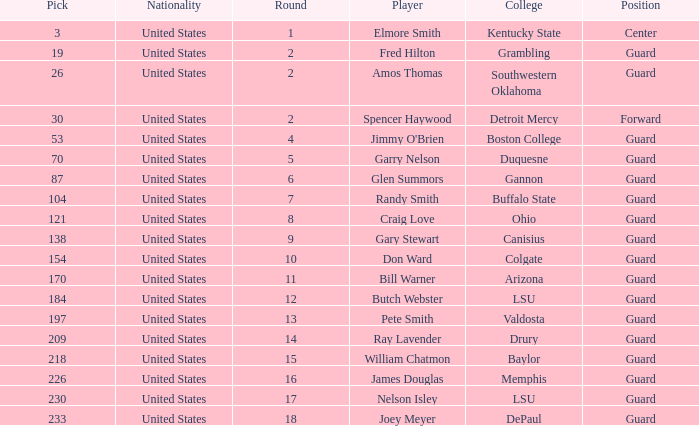WHAT POSITION HAS A ROUND LARGER THAN 2, FOR VALDOSTA COLLEGE? Guard. 